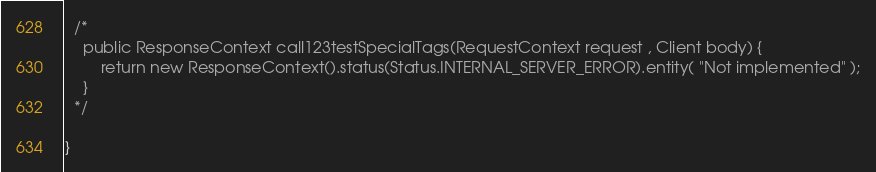Convert code to text. <code><loc_0><loc_0><loc_500><loc_500><_Java_>
  /*
    public ResponseContext call123testSpecialTags(RequestContext request , Client body) {
        return new ResponseContext().status(Status.INTERNAL_SERVER_ERROR).entity( "Not implemented" );
    }
  */

}
</code> 